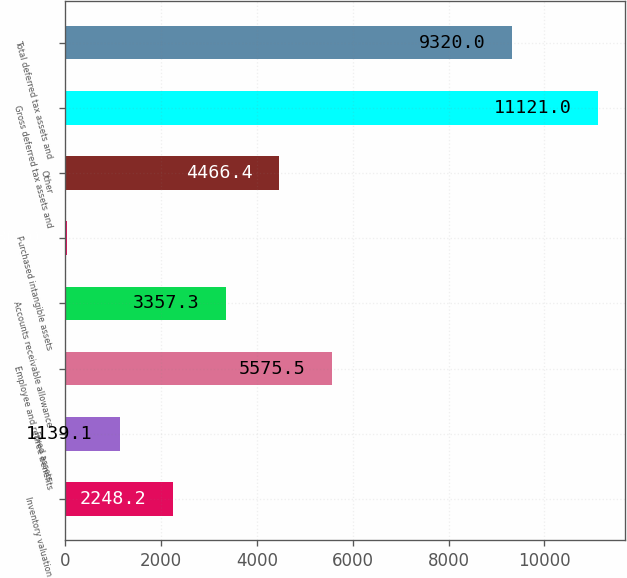Convert chart to OTSL. <chart><loc_0><loc_0><loc_500><loc_500><bar_chart><fcel>Inventory valuation<fcel>Fixed assets<fcel>Employee and retiree benefits<fcel>Accounts receivable allowance<fcel>Purchased intangible assets<fcel>Other<fcel>Gross deferred tax assets and<fcel>Total deferred tax assets and<nl><fcel>2248.2<fcel>1139.1<fcel>5575.5<fcel>3357.3<fcel>30<fcel>4466.4<fcel>11121<fcel>9320<nl></chart> 